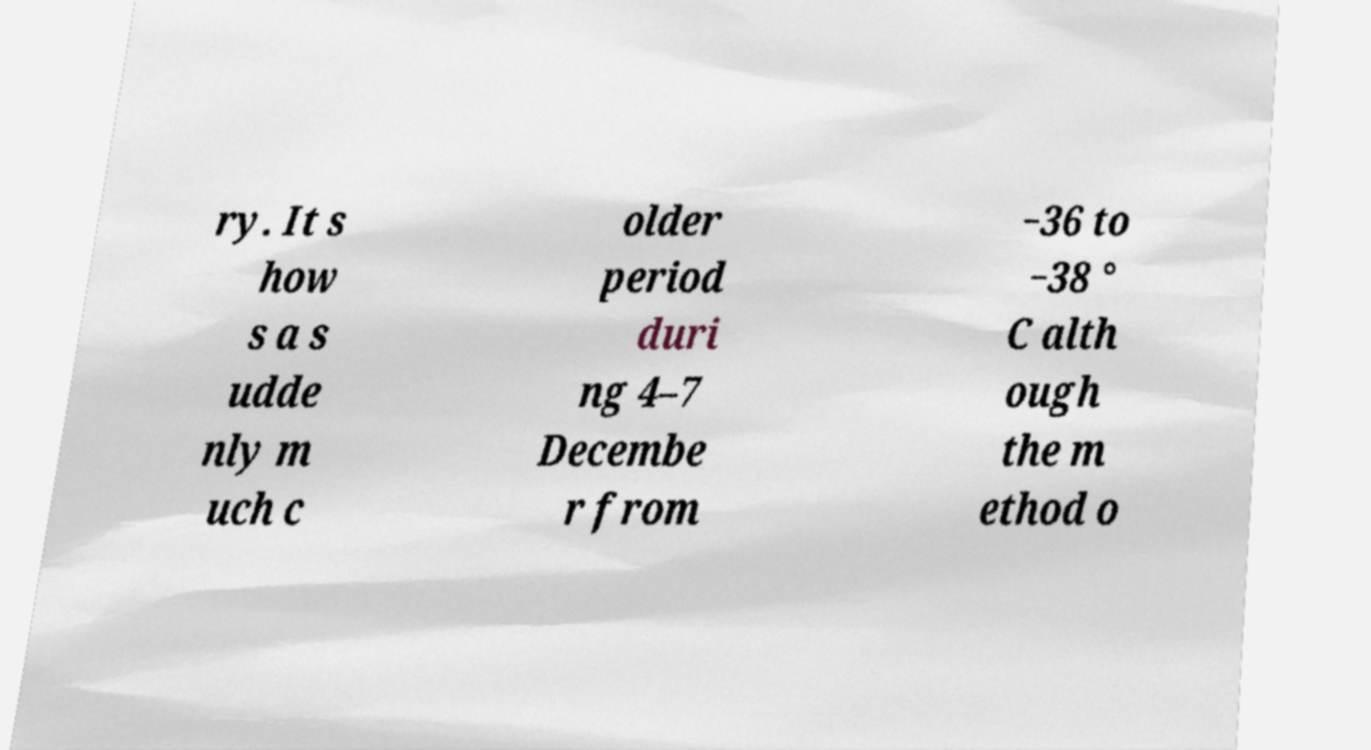What messages or text are displayed in this image? I need them in a readable, typed format. ry. It s how s a s udde nly m uch c older period duri ng 4–7 Decembe r from −36 to −38 ° C alth ough the m ethod o 